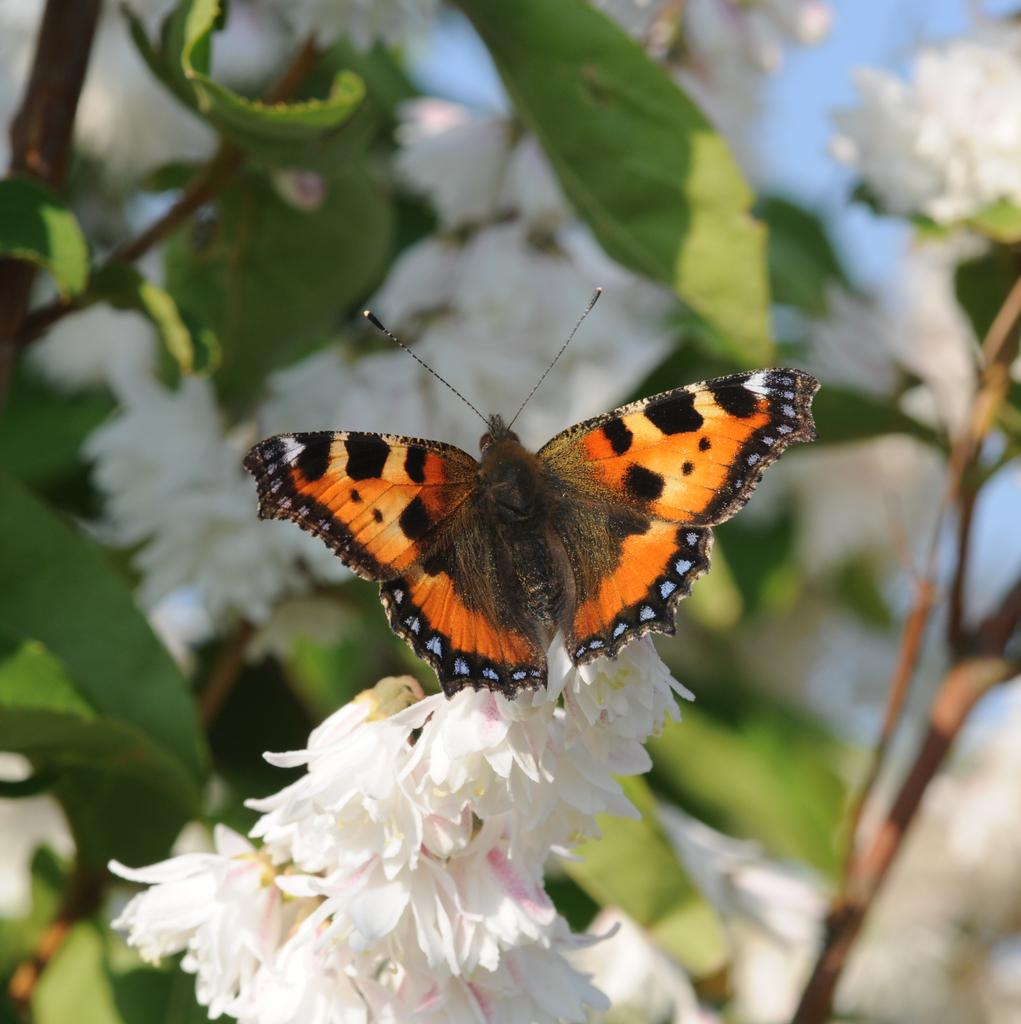What is the main subject of the picture? There is a butterfly in the picture. What can be seen in the foreground of the picture? There are flowers in the foreground of the picture. How would you describe the background of the picture? The background of the picture is blurred. What else can be seen in the background of the picture? There are flowers of a plant in the background of the picture. What is the weather like in the picture? It is sunny. Can you see a quilt being kicked in the picture? There is no quilt or any kicking activity present in the image. 